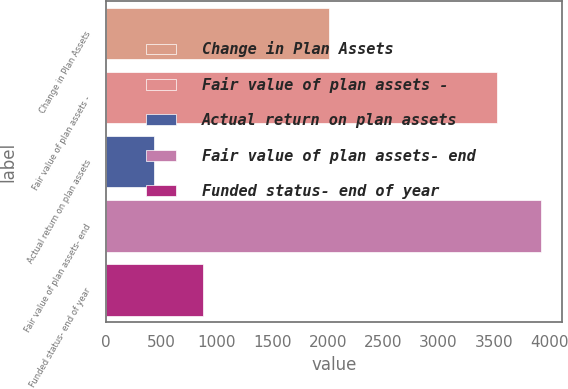<chart> <loc_0><loc_0><loc_500><loc_500><bar_chart><fcel>Change in Plan Assets<fcel>Fair value of plan assets -<fcel>Actual return on plan assets<fcel>Fair value of plan assets- end<fcel>Funded status- end of year<nl><fcel>2010<fcel>3526<fcel>434<fcel>3922<fcel>873<nl></chart> 